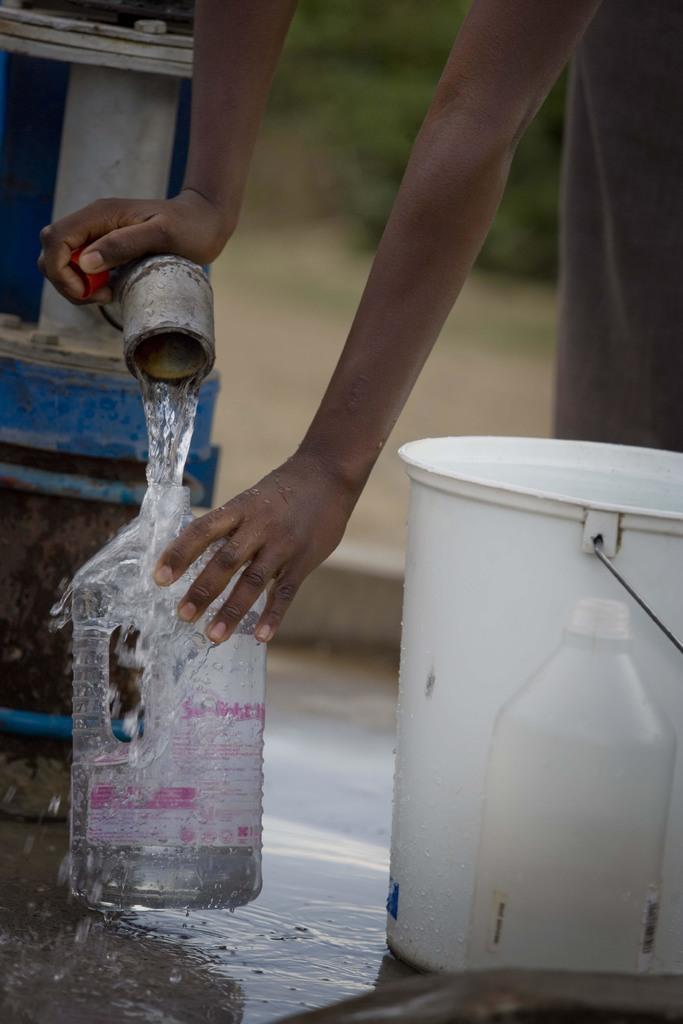Could you give a brief overview of what you see in this image? This picture shows a man filling a water bottle with water from the pipe and we see a bucket and a bottle on the side 